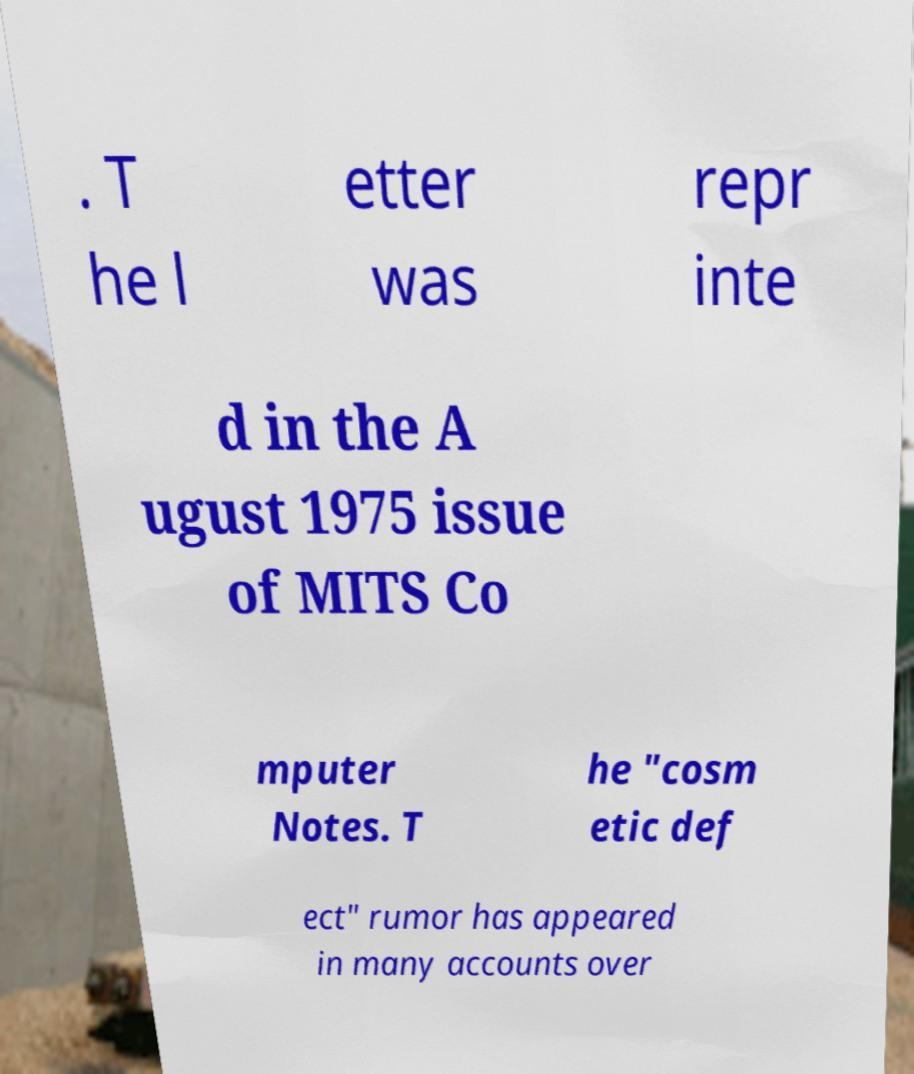Could you assist in decoding the text presented in this image and type it out clearly? . T he l etter was repr inte d in the A ugust 1975 issue of MITS Co mputer Notes. T he "cosm etic def ect" rumor has appeared in many accounts over 